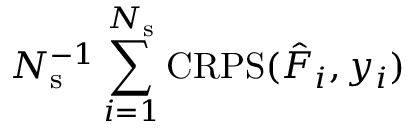<formula> <loc_0><loc_0><loc_500><loc_500>N _ { s } ^ { - 1 } \sum _ { i = 1 } ^ { N _ { s } } C R P S ( \hat { F } _ { i } , y _ { i } )</formula> 